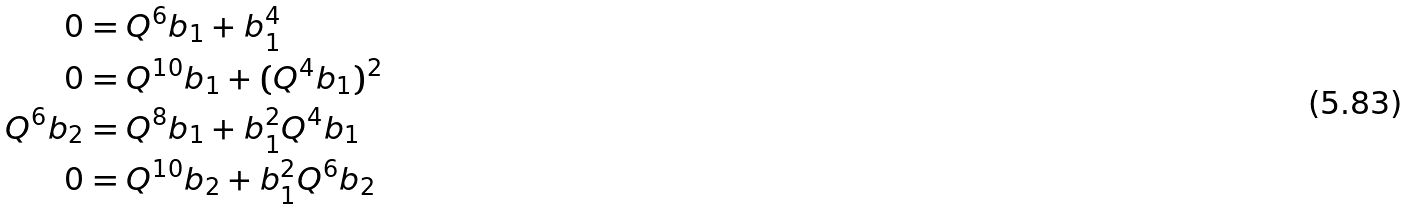Convert formula to latex. <formula><loc_0><loc_0><loc_500><loc_500>0 & = Q ^ { 6 } b _ { 1 } + b _ { 1 } ^ { 4 } \\ 0 & = Q ^ { 1 0 } b _ { 1 } + ( Q ^ { 4 } b _ { 1 } ) ^ { 2 } \\ Q ^ { 6 } b _ { 2 } & = Q ^ { 8 } b _ { 1 } + b _ { 1 } ^ { 2 } Q ^ { 4 } b _ { 1 } \\ 0 & = Q ^ { 1 0 } b _ { 2 } + b _ { 1 } ^ { 2 } Q ^ { 6 } b _ { 2 } \\</formula> 